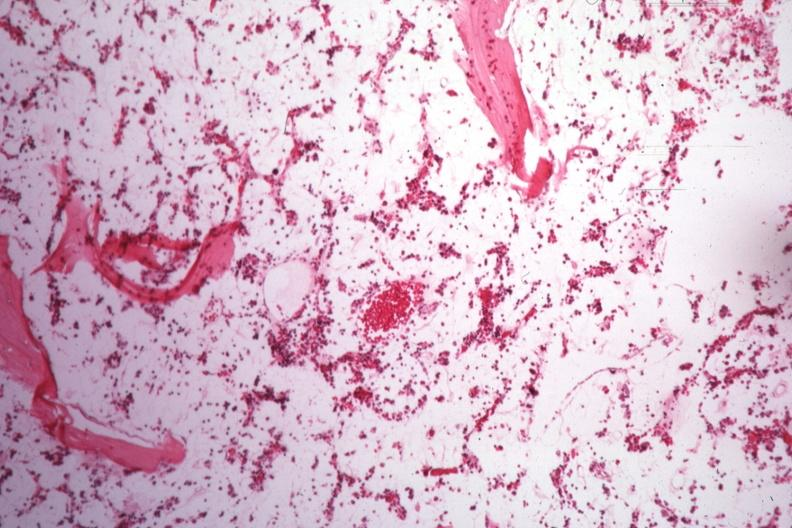what is present?
Answer the question using a single word or phrase. Aplastic 